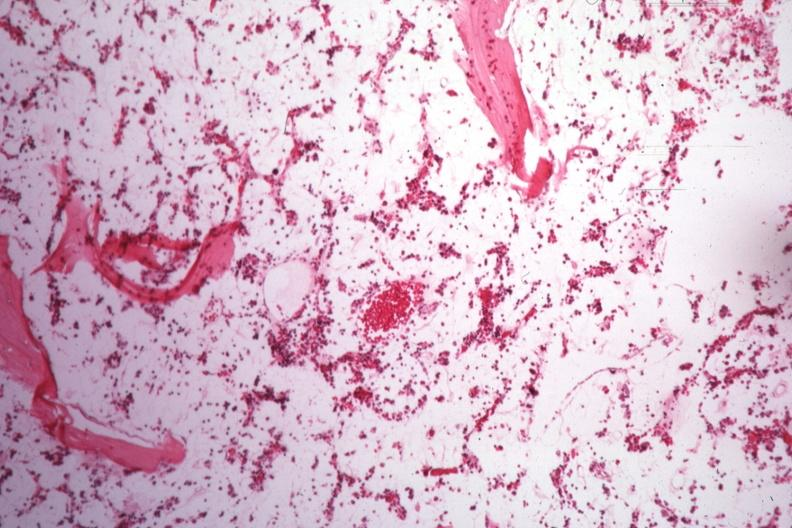what is present?
Answer the question using a single word or phrase. Aplastic 